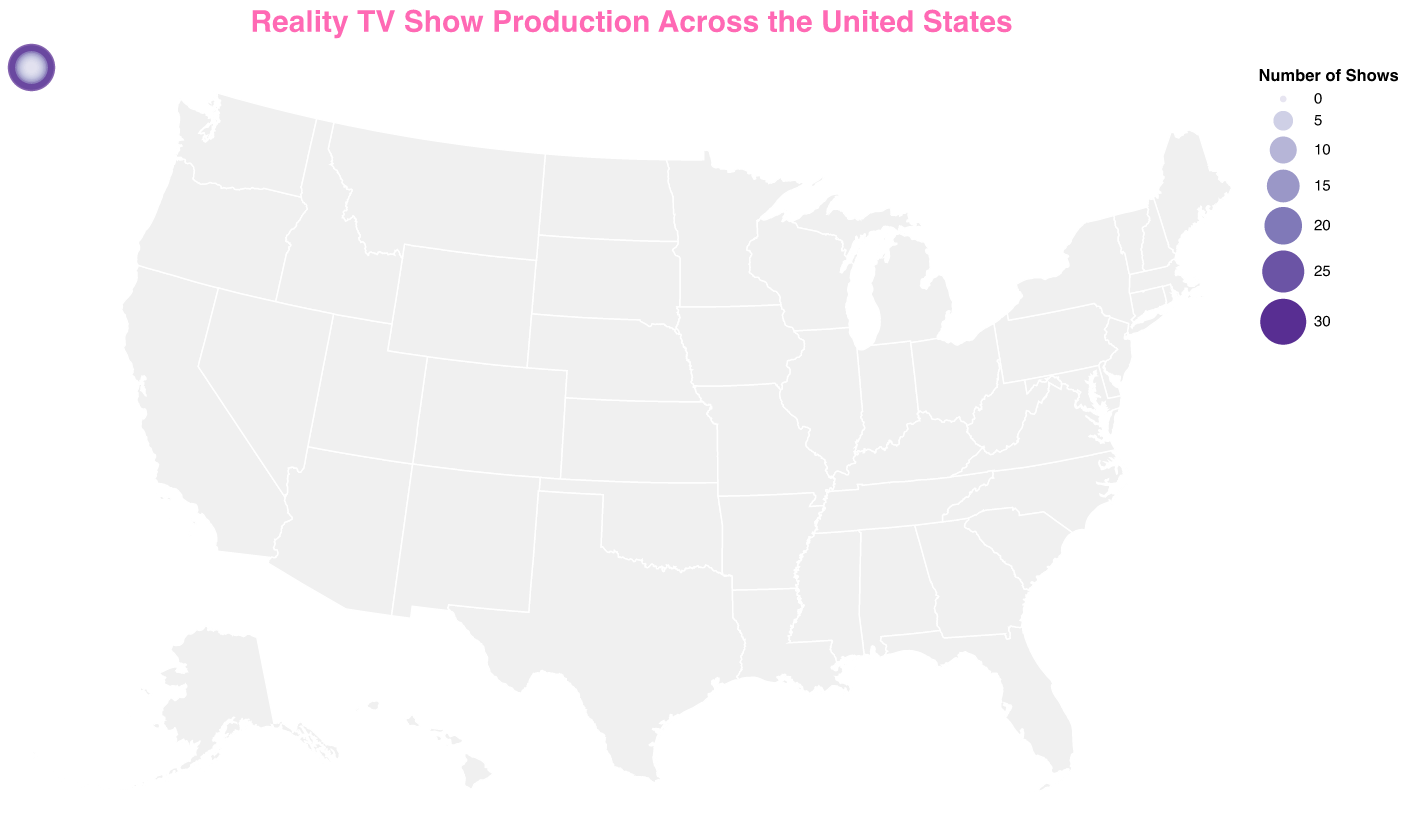What's the title of the figure? The title of the figure is shown at the top. It reads "Reality TV Show Production Across the United States."
Answer: Reality TV Show Production Across the United States Which state has the highest number of reality TV shows produced? The size and color of the circles indicate the number of shows per state. The largest and darkest circle is over California, which has 32 shows.
Answer: California How many states have produced more than 10 reality TV shows? By observing the circles representing the number of shows, states with more than 10 shows are California, New York, Florida, Texas, and Georgia. Counting them gives a total of 5 states.
Answer: 5 Which states have produced only 1 reality TV show? The smallest circles represent states with only 1 show. These states are Ohio, Utah, and Michigan, as seen by their minimal circle size.
Answer: Ohio, Utah, Michigan What is the combined number of reality TV shows produced in New York and Florida? Adding the number of shows from New York and Florida: 28 (New York) + 15 (Florida) = 43
Answer: 43 Is the number of shows produced in Nevada greater than in Tennessee? By comparing the circle sizes or numbers, Nevada has 7 shows while Tennessee has 5 shows. 7 is greater than 5.
Answer: Yes Among Georgia, Illinois, and Nevada, which state has the least number of reality TV shows? Comparing the circles, Illinois has 8, Georgia has 10, and Nevada has 7. Nevada has the least among the three.
Answer: Nevada How much more shows does California produce compared to Texas? Subtract the number of shows in Texas from those in California: 32 (California) - 12 (Texas) = 20
Answer: 20 Which state is represented with a circle of medium size and color, indicating a moderate number of reality TV shows? States with a moderate number of shows (around the middle of the dataset) include Illinois (8 shows) and Nevada (7 shows) as they show medium-sized and medium-colored circles.
Answer: Illinois or Nevada 